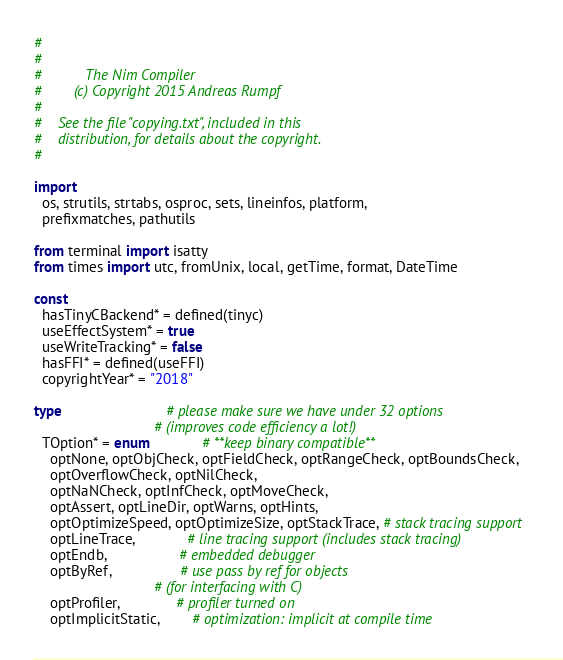Convert code to text. <code><loc_0><loc_0><loc_500><loc_500><_Nim_>#
#
#           The Nim Compiler
#        (c) Copyright 2015 Andreas Rumpf
#
#    See the file "copying.txt", included in this
#    distribution, for details about the copyright.
#

import
  os, strutils, strtabs, osproc, sets, lineinfos, platform,
  prefixmatches, pathutils

from terminal import isatty
from times import utc, fromUnix, local, getTime, format, DateTime

const
  hasTinyCBackend* = defined(tinyc)
  useEffectSystem* = true
  useWriteTracking* = false
  hasFFI* = defined(useFFI)
  copyrightYear* = "2018"

type                          # please make sure we have under 32 options
                              # (improves code efficiency a lot!)
  TOption* = enum             # **keep binary compatible**
    optNone, optObjCheck, optFieldCheck, optRangeCheck, optBoundsCheck,
    optOverflowCheck, optNilCheck,
    optNaNCheck, optInfCheck, optMoveCheck,
    optAssert, optLineDir, optWarns, optHints,
    optOptimizeSpeed, optOptimizeSize, optStackTrace, # stack tracing support
    optLineTrace,             # line tracing support (includes stack tracing)
    optEndb,                  # embedded debugger
    optByRef,                 # use pass by ref for objects
                              # (for interfacing with C)
    optProfiler,              # profiler turned on
    optImplicitStatic,        # optimization: implicit at compile time</code> 